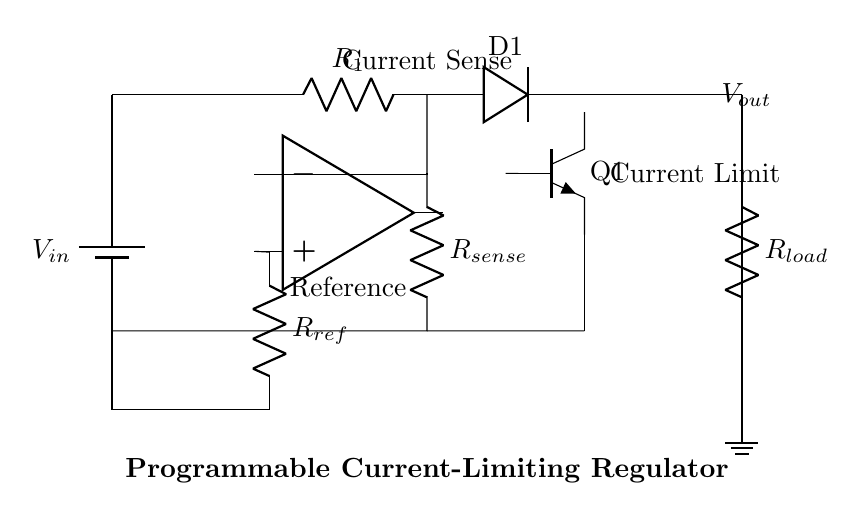What is the purpose of the transistor in this circuit? The transistor is used to control the current flowing through the load by acting as a switch or amplifier depending on the base current. It allows the circuit to limit the output current to a safe level for sensitive components.
Answer: Current control What is the reference resistor labeled as? The resistor is labeled as R_ref, which sets the reference voltage for the operational amplifier to determine the safe current limit.
Answer: R_ref What does R_sense measure? R_sense is a current sense resistor that measures the current flowing to the load by producing a voltage drop proportional to the load current, which is used to compare against the reference voltage.
Answer: Load current How many operational amplifiers are used in this circuit? There is one operational amplifier used to compare the sensed voltage across R_sense with the reference voltage, enabling the current limiting function.
Answer: One What is the relationship between V_in and V_out? V_out is derived from V_in and regulated by the circuit to ensure the output does not exceed a specified current limit, thus protecting the load.
Answer: Regulated output What component limits the current in this circuit? The current is limited by the combination of R_sense and the operational amplifier, which controls the transistor when the sensed current exceeds the reference set by R_ref.
Answer: R_sense and op-amp What does R_load represent? R_load represents the load being powered by the regulator. Its resistance determines how much current it draws from the regulator's output.
Answer: Load resistance 